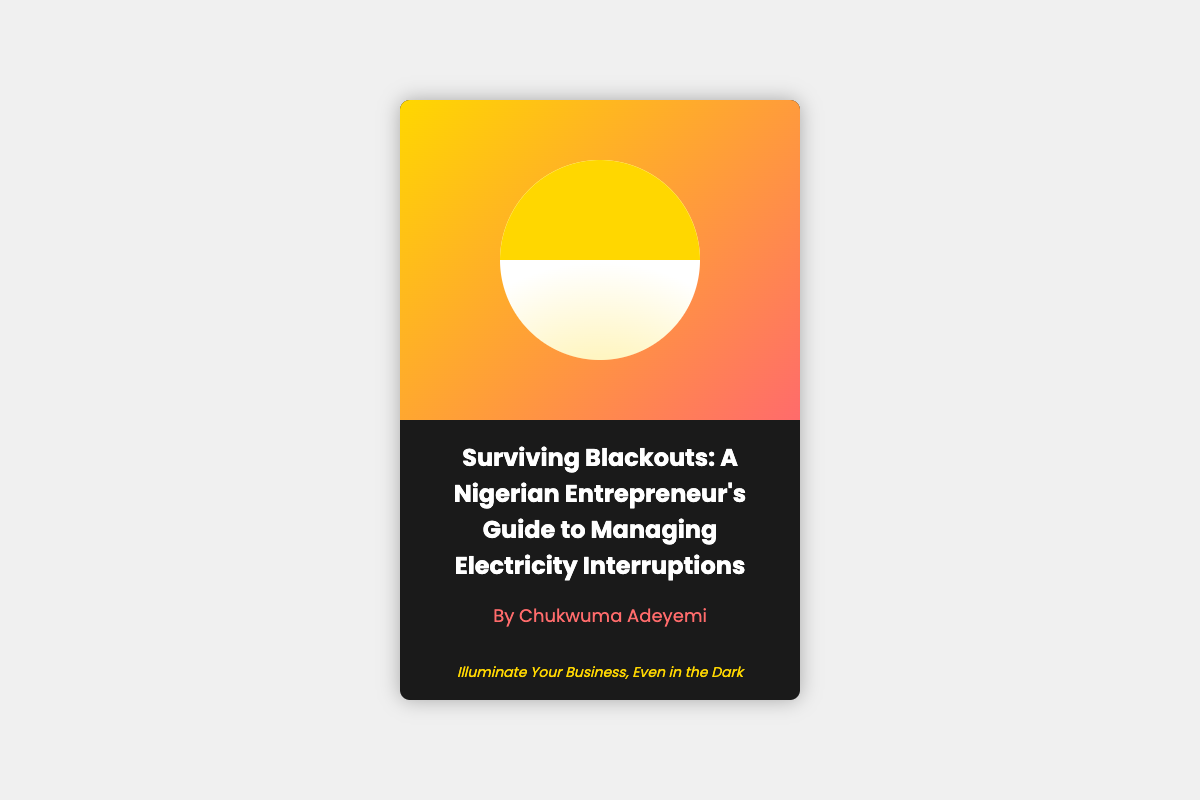What is the title of the book? The title is prominently displayed at the top of the cover.
Answer: Surviving Blackouts: A Nigerian Entrepreneur's Guide to Managing Electricity Interruptions Who is the author of the book? The author's name is provided near the title on the cover.
Answer: Chukwuma Adeyemi What color is the lightbulb on the cover? The lightbulb is primarily white with a golden top half.
Answer: White What does the tagline suggest? The tagline is meant to express the essence of the book's message regarding business in challenging circumstances.
Answer: Illuminate Your Business, Even in the Dark What percentage of the cover is taken up by the cover image? The cover image occupies the upper portion of the book cover.
Answer: 60% What is the main theme of the book? The book focuses on strategies for entrepreneurs to deal with frequent electricity interruptions.
Answer: Managing Electricity Interruptions How many colors can be primarily seen on the cover? The cover features a combination of key colors in the gradient and text.
Answer: Three Is the cover design more modern or traditional? The design appears contemporary with its use of gradients and icons.
Answer: Modern 